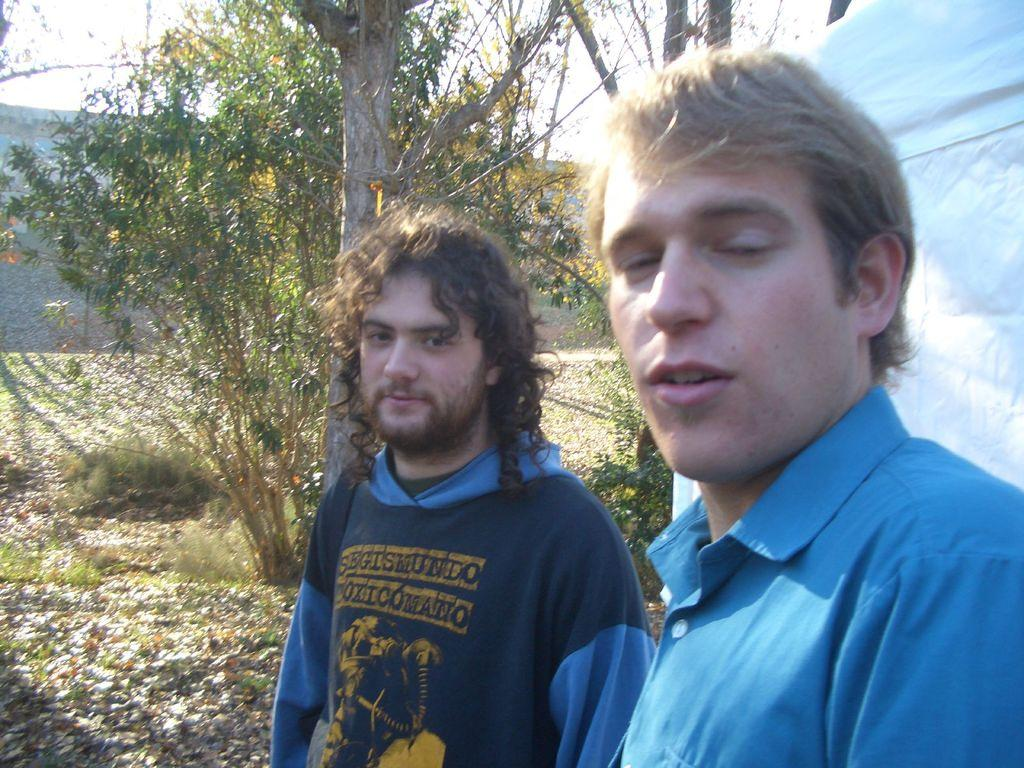How many people are in the image? There are two men in the middle of the image. What can be seen in the background of the image? There are trees in the background of the image. What is on the ground in the image? There are leaves on the ground in the image. What is located on the right side of the image? There is a white cloth on the right side of the image. What type of corn is growing in the image? There is no corn present in the image. How many horses can be seen in the image? There are no horses present in the image. 